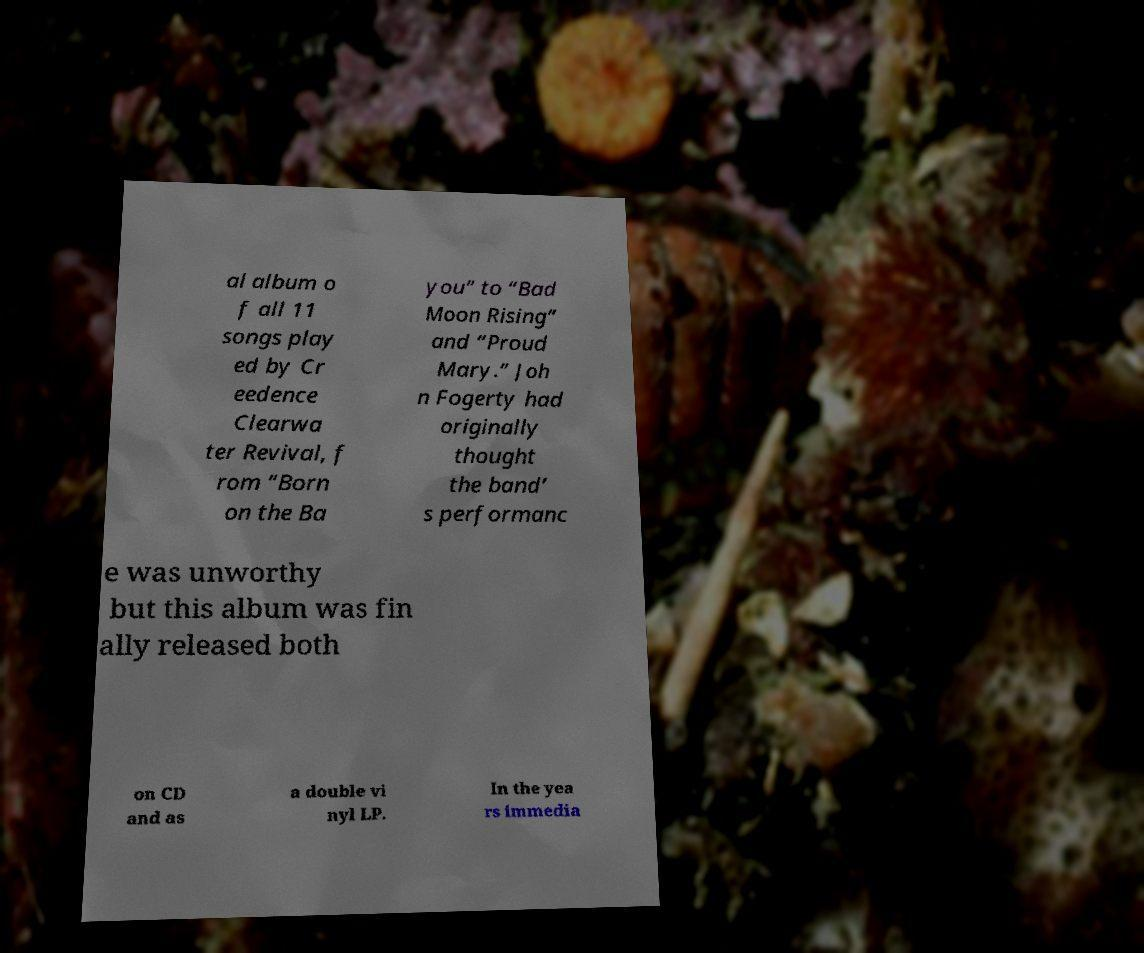Please identify and transcribe the text found in this image. al album o f all 11 songs play ed by Cr eedence Clearwa ter Revival, f rom “Born on the Ba you” to “Bad Moon Rising” and “Proud Mary.” Joh n Fogerty had originally thought the band’ s performanc e was unworthy but this album was fin ally released both on CD and as a double vi nyl LP. In the yea rs immedia 